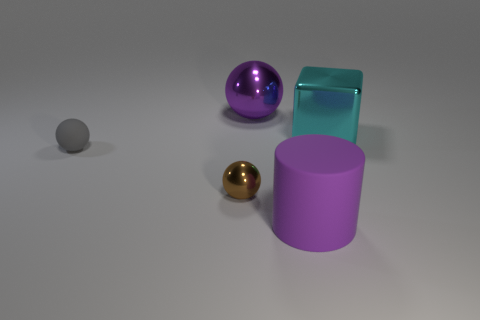Subtract all metal spheres. How many spheres are left? 1 Add 4 tiny rubber balls. How many objects exist? 9 Subtract all cyan balls. Subtract all blue cubes. How many balls are left? 3 Subtract all blocks. How many objects are left? 4 Subtract 0 cyan spheres. How many objects are left? 5 Subtract all matte cylinders. Subtract all red metal cylinders. How many objects are left? 4 Add 2 big purple shiny things. How many big purple shiny things are left? 3 Add 3 gray matte balls. How many gray matte balls exist? 4 